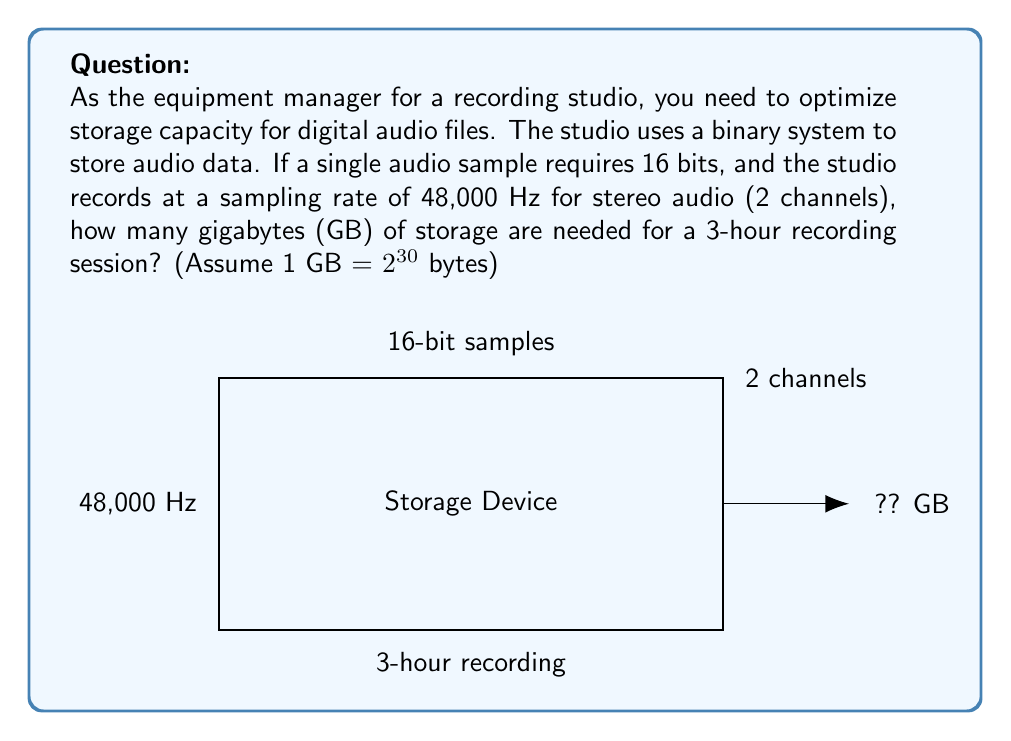Can you answer this question? Let's break this down step-by-step:

1) First, calculate the number of samples per second:
   $$ \text{Samples per second} = 48,000 \text{ Hz} \times 2 \text{ channels} = 96,000 $$

2) Calculate the number of bits per second:
   $$ \text{Bits per second} = 96,000 \text{ samples/s} \times 16 \text{ bits/sample} = 1,536,000 \text{ bits/s} $$

3) Convert bits per second to bytes per second:
   $$ \text{Bytes per second} = 1,536,000 \text{ bits/s} \div 8 \text{ bits/byte} = 192,000 \text{ bytes/s} $$

4) Calculate total bytes for 3 hours:
   $$ \text{Total bytes} = 192,000 \text{ bytes/s} \times 3 \text{ hours} \times 3600 \text{ s/hour} = 2,073,600,000 \text{ bytes} $$

5) Convert bytes to gigabytes:
   $$ \text{GB} = \frac{2,073,600,000 \text{ bytes}}{2^{30} \text{ bytes/GB}} \approx 1.93 \text{ GB} $$
Answer: 1.93 GB 